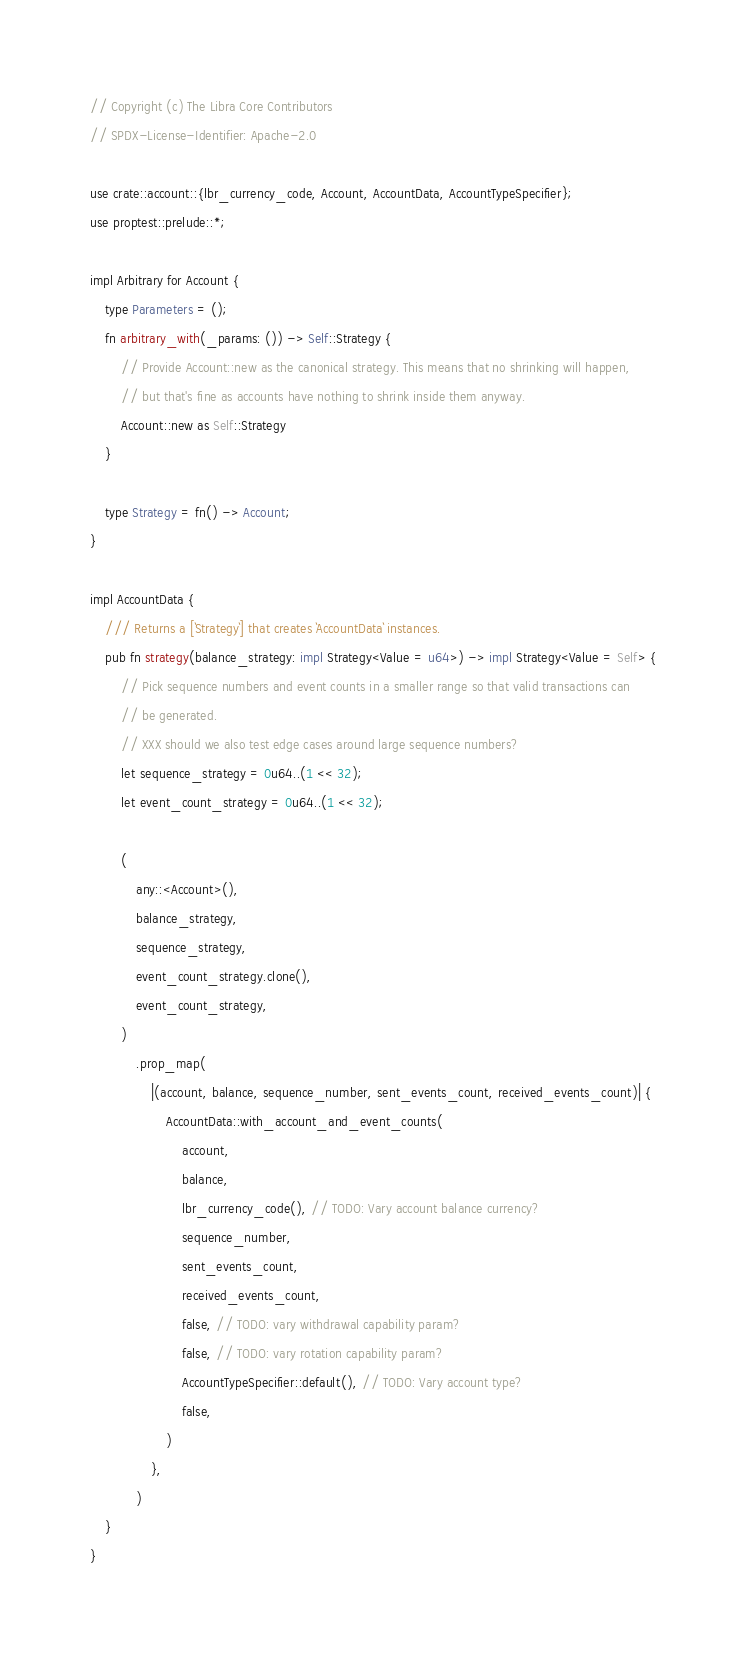<code> <loc_0><loc_0><loc_500><loc_500><_Rust_>// Copyright (c) The Libra Core Contributors
// SPDX-License-Identifier: Apache-2.0

use crate::account::{lbr_currency_code, Account, AccountData, AccountTypeSpecifier};
use proptest::prelude::*;

impl Arbitrary for Account {
    type Parameters = ();
    fn arbitrary_with(_params: ()) -> Self::Strategy {
        // Provide Account::new as the canonical strategy. This means that no shrinking will happen,
        // but that's fine as accounts have nothing to shrink inside them anyway.
        Account::new as Self::Strategy
    }

    type Strategy = fn() -> Account;
}

impl AccountData {
    /// Returns a [`Strategy`] that creates `AccountData` instances.
    pub fn strategy(balance_strategy: impl Strategy<Value = u64>) -> impl Strategy<Value = Self> {
        // Pick sequence numbers and event counts in a smaller range so that valid transactions can
        // be generated.
        // XXX should we also test edge cases around large sequence numbers?
        let sequence_strategy = 0u64..(1 << 32);
        let event_count_strategy = 0u64..(1 << 32);

        (
            any::<Account>(),
            balance_strategy,
            sequence_strategy,
            event_count_strategy.clone(),
            event_count_strategy,
        )
            .prop_map(
                |(account, balance, sequence_number, sent_events_count, received_events_count)| {
                    AccountData::with_account_and_event_counts(
                        account,
                        balance,
                        lbr_currency_code(), // TODO: Vary account balance currency?
                        sequence_number,
                        sent_events_count,
                        received_events_count,
                        false, // TODO: vary withdrawal capability param?
                        false, // TODO: vary rotation capability param?
                        AccountTypeSpecifier::default(), // TODO: Vary account type?
                        false,
                    )
                },
            )
    }
}
</code> 